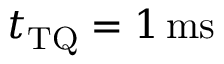Convert formula to latex. <formula><loc_0><loc_0><loc_500><loc_500>t _ { T Q } = 1 { \, m s }</formula> 